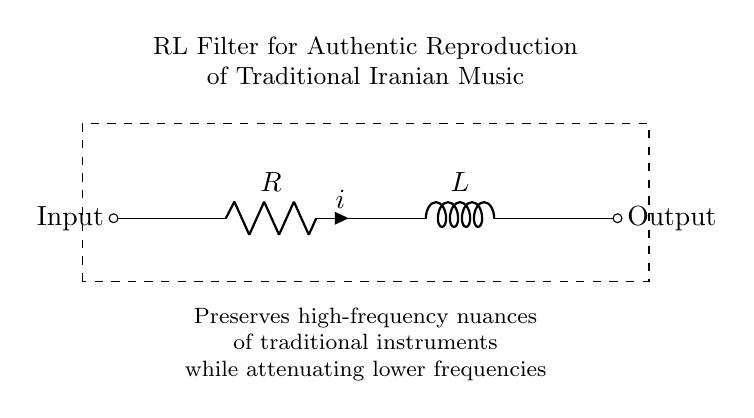What are the components of this circuit? The circuit includes a resistor and an inductor, clearly labeled as R and L, respectively.
Answer: Resistor and Inductor What is the main function of this RL filter? The primary function of the RL filter is to preserve high-frequency nuances while attenuating lower frequencies, which is essential for authentic reproduction of traditional Iranian music.
Answer: Authentic reproduction What type of filter does this RL circuit represent? This RL circuit represents a low-pass filter, as it allows low frequencies to pass through while attenuating higher frequencies due to the properties of the inductor in the circuit.
Answer: Low-pass filter What is the relation between current and voltage in this RL circuit? In an RL circuit, the current lags the voltage by a phase angle that increases with frequency, indicating the presence of reactive components in the circuit (the inductor).
Answer: Current lags voltage What does the dashed rectangle around the circuit signify? The dashed rectangle is typically used to enclose the circuit components to indicate that they form a distinct functional block, which in this case is an RL filter used for audio applications.
Answer: Functional block What happens to the output signal when lower frequencies are attenuated? When lower frequencies are attenuated, the output signal primarily consists of higher frequencies, which helps maintain the clarity and quality of the sound produced from traditional Iranian music instruments.
Answer: Output consists of higher frequencies 